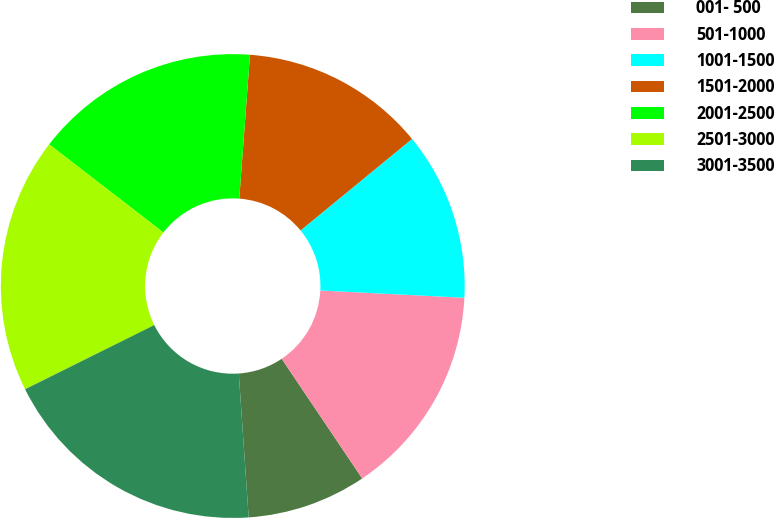<chart> <loc_0><loc_0><loc_500><loc_500><pie_chart><fcel>001- 500<fcel>501-1000<fcel>1001-1500<fcel>1501-2000<fcel>2001-2500<fcel>2501-3000<fcel>3001-3500<nl><fcel>8.33%<fcel>14.77%<fcel>11.74%<fcel>12.88%<fcel>15.72%<fcel>17.8%<fcel>18.75%<nl></chart> 